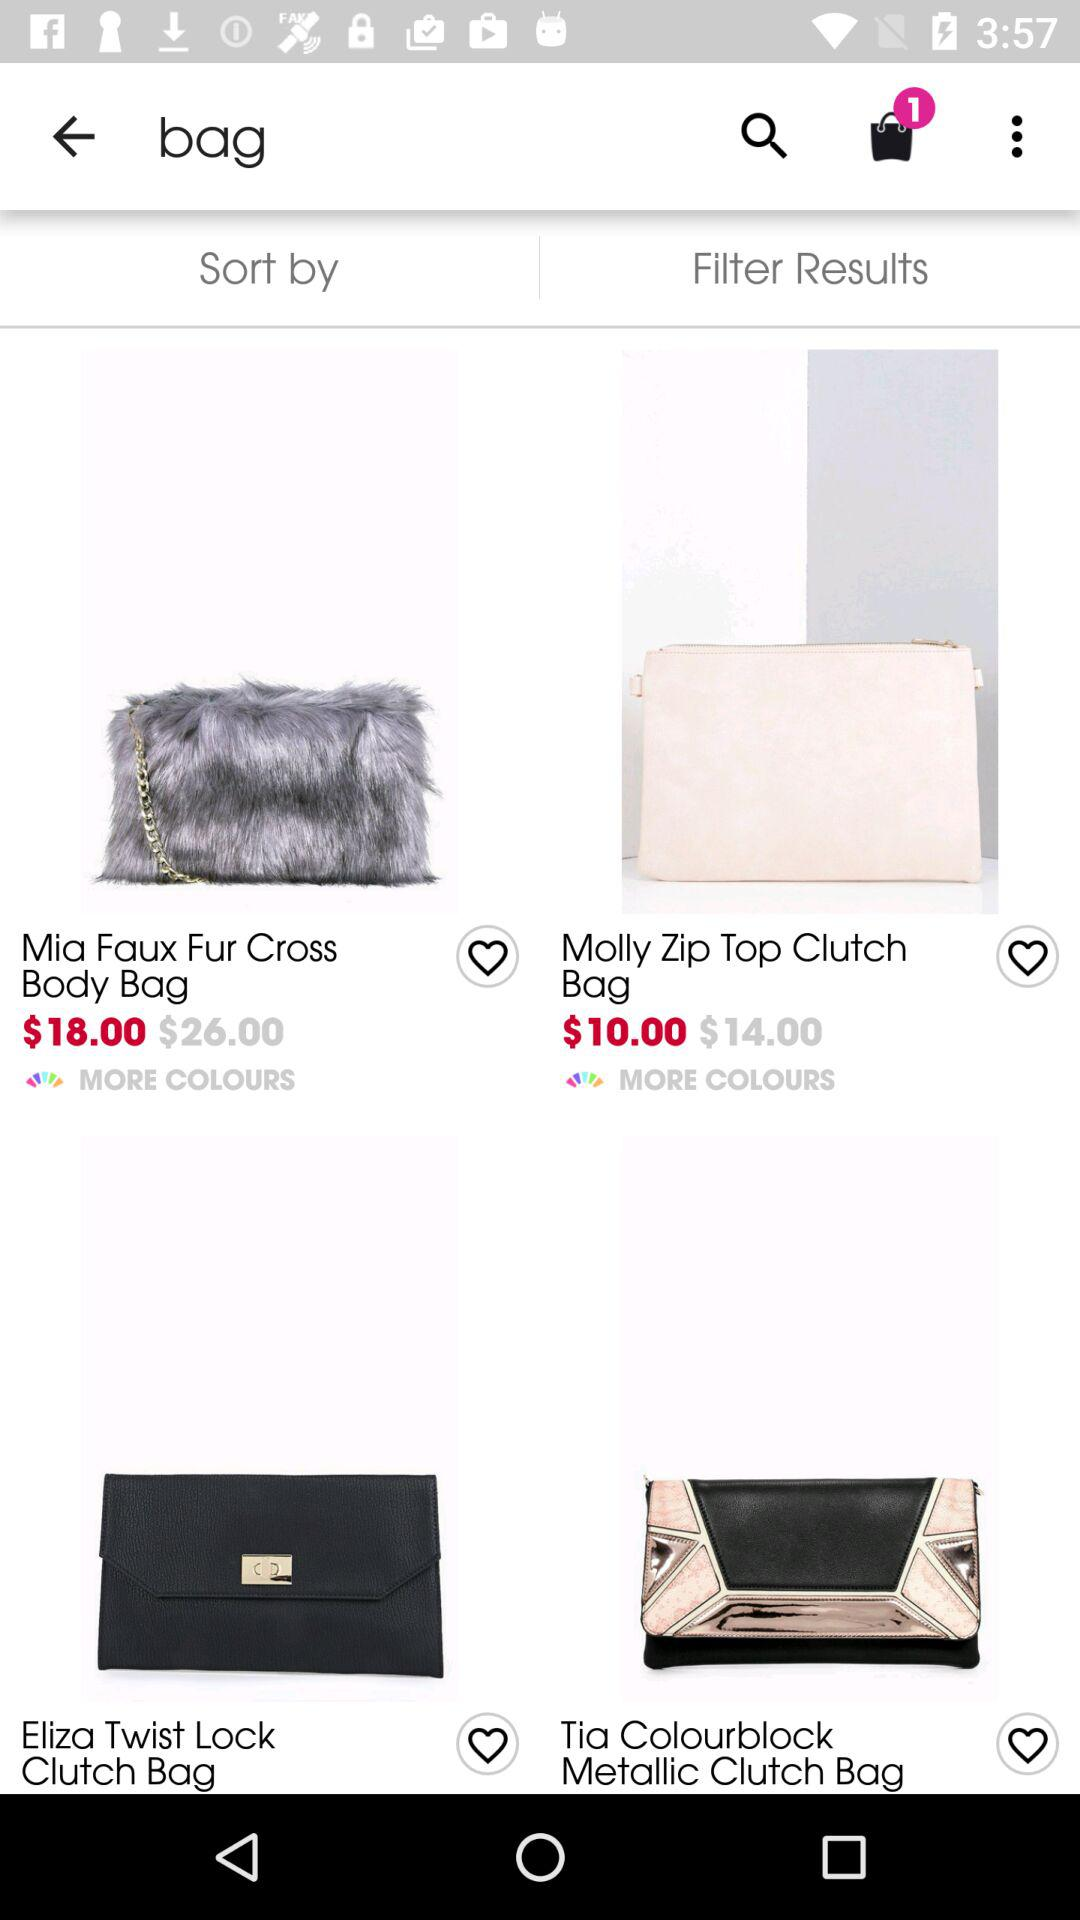For what item has the person searched? The person has searched for "bag". 